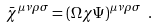Convert formula to latex. <formula><loc_0><loc_0><loc_500><loc_500>\bar { \chi } ^ { \mu \nu \rho \sigma } = ( \Omega \chi \Psi ) ^ { \mu \nu \rho \sigma } \ .</formula> 